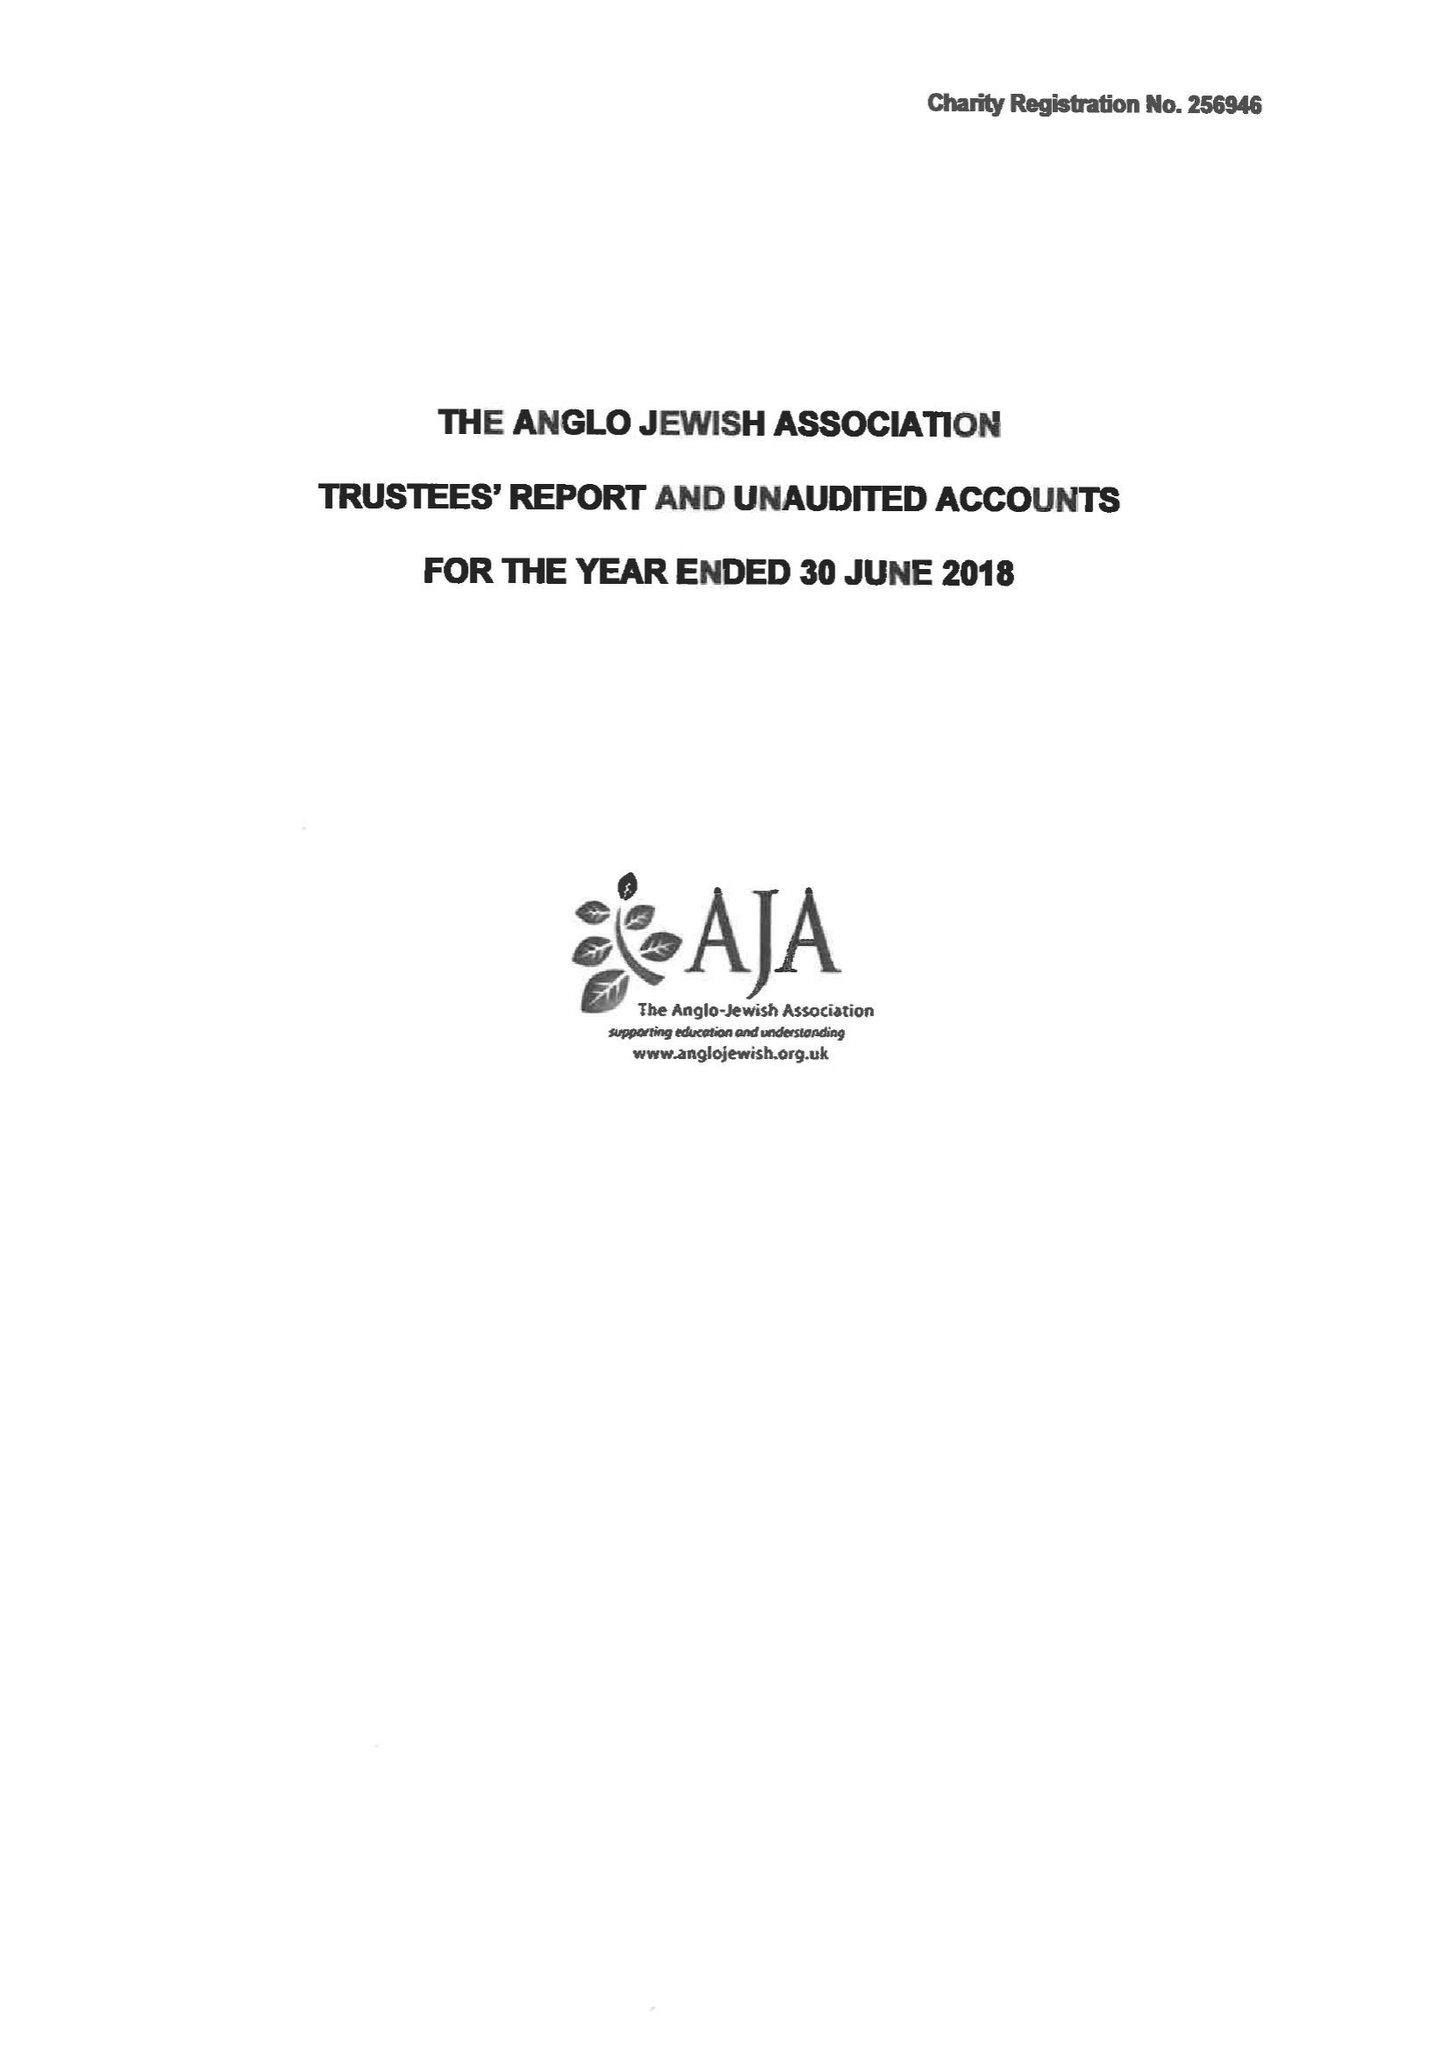What is the value for the spending_annually_in_british_pounds?
Answer the question using a single word or phrase. 91522.00 